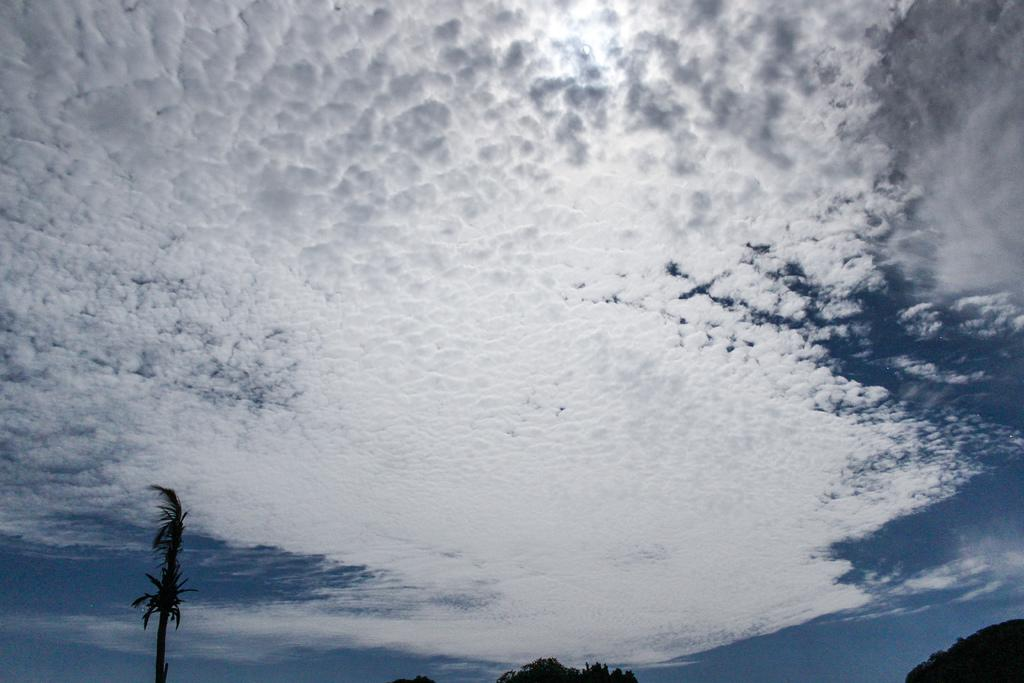What is the condition of the sky in the image? The sky is covered with clouds in the image. What type of natural vegetation can be seen in the image? There are trees visible in the image. How many sisters are playing basketball in the image? There are no sisters or basketball players present in the image. 